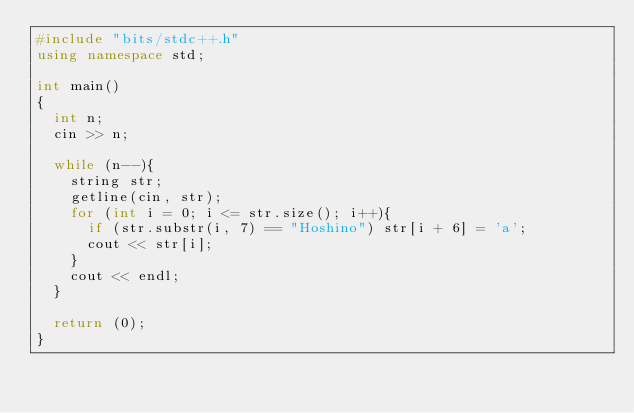Convert code to text. <code><loc_0><loc_0><loc_500><loc_500><_C++_>#include "bits/stdc++.h"
using namespace std;

int main()
{
  int n;
  cin >> n;

  while (n--){
    string str;
    getline(cin, str);
    for (int i = 0; i <= str.size(); i++){
      if (str.substr(i, 7) == "Hoshino") str[i + 6] = 'a';
      cout << str[i];
    }
    cout << endl;
  }

  return (0);
}</code> 